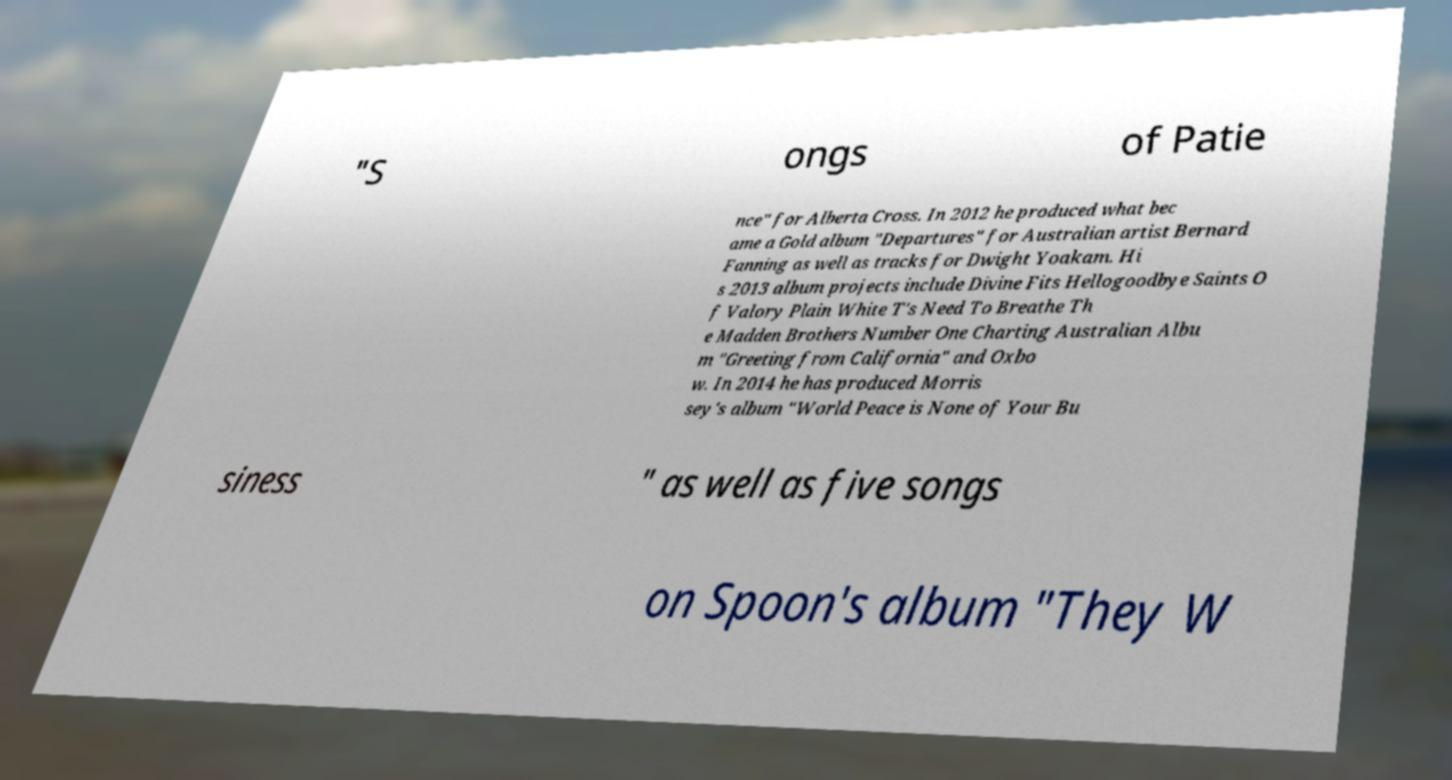Can you read and provide the text displayed in the image?This photo seems to have some interesting text. Can you extract and type it out for me? "S ongs of Patie nce" for Alberta Cross. In 2012 he produced what bec ame a Gold album "Departures" for Australian artist Bernard Fanning as well as tracks for Dwight Yoakam. Hi s 2013 album projects include Divine Fits Hellogoodbye Saints O f Valory Plain White T's Need To Breathe Th e Madden Brothers Number One Charting Australian Albu m "Greeting from California" and Oxbo w. In 2014 he has produced Morris sey's album "World Peace is None of Your Bu siness " as well as five songs on Spoon's album "They W 